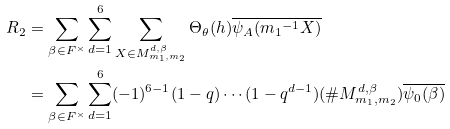Convert formula to latex. <formula><loc_0><loc_0><loc_500><loc_500>R _ { 2 } & = \sum _ { \beta \in F ^ { \times } } \sum _ { d = 1 } ^ { 6 } \sum _ { X \in M _ { m _ { 1 } , m _ { 2 } } ^ { d , \beta } } \Theta _ { \theta } ( h ) \overline { \psi _ { A } ( { m _ { 1 } } ^ { - 1 } X ) } \\ & = \sum _ { \beta \in F ^ { \times } } \sum _ { d = 1 } ^ { 6 } ( - 1 ) ^ { 6 - 1 } ( 1 - q ) \cdots ( 1 - q ^ { d - 1 } ) ( \# M _ { m _ { 1 } , m _ { 2 } } ^ { d , \beta } ) \overline { \psi _ { 0 } ( \beta ) }</formula> 